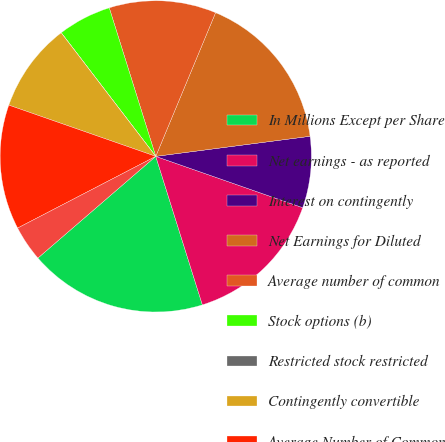Convert chart to OTSL. <chart><loc_0><loc_0><loc_500><loc_500><pie_chart><fcel>In Millions Except per Share<fcel>Net earnings - as reported<fcel>Interest on contingently<fcel>Net Earnings for Diluted<fcel>Average number of common<fcel>Stock options (b)<fcel>Restricted stock restricted<fcel>Contingently convertible<fcel>Average Number of Common<fcel>Earnings per Share - Basic<nl><fcel>18.51%<fcel>14.81%<fcel>7.41%<fcel>16.66%<fcel>11.11%<fcel>5.56%<fcel>0.01%<fcel>9.26%<fcel>12.96%<fcel>3.71%<nl></chart> 